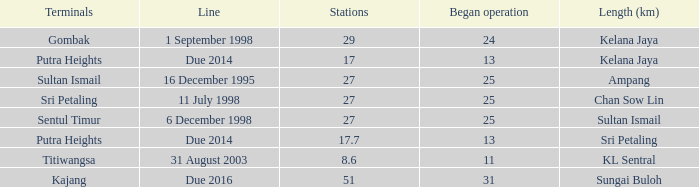When is the earliest began operation with a length of sultan ismail and over 27 stations? None. 